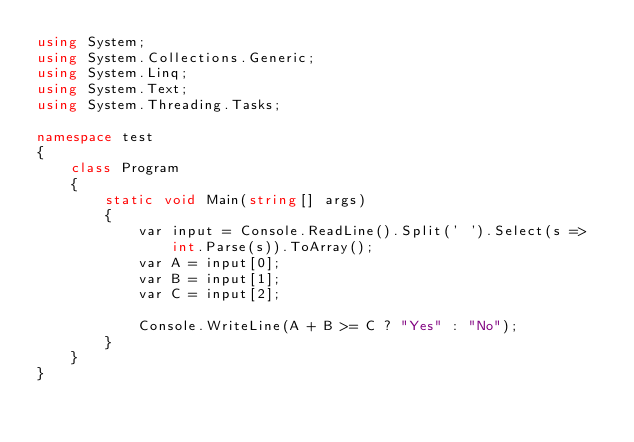Convert code to text. <code><loc_0><loc_0><loc_500><loc_500><_C#_>using System;
using System.Collections.Generic;
using System.Linq;
using System.Text;
using System.Threading.Tasks;

namespace test
{
    class Program
    {
        static void Main(string[] args)
        {
            var input = Console.ReadLine().Split(' ').Select(s => int.Parse(s)).ToArray();
            var A = input[0];
            var B = input[1];
            var C = input[2];

            Console.WriteLine(A + B >= C ? "Yes" : "No");
        }
    }
}</code> 